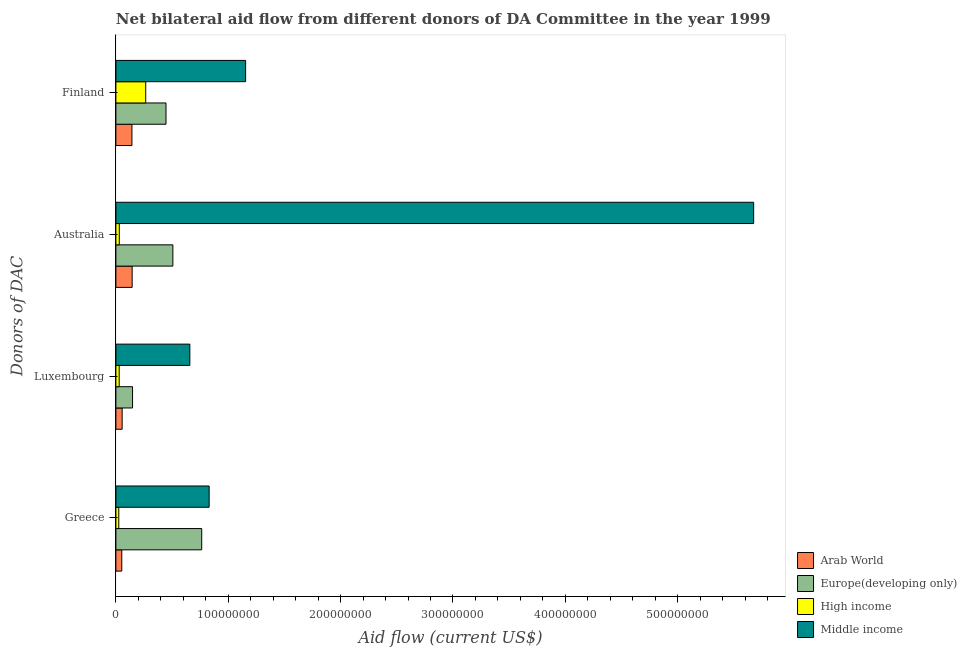How many groups of bars are there?
Ensure brevity in your answer.  4. Are the number of bars per tick equal to the number of legend labels?
Your answer should be very brief. Yes. How many bars are there on the 3rd tick from the bottom?
Your answer should be compact. 4. What is the label of the 3rd group of bars from the top?
Provide a succinct answer. Luxembourg. What is the amount of aid given by australia in High income?
Provide a succinct answer. 3.03e+06. Across all countries, what is the maximum amount of aid given by australia?
Provide a short and direct response. 5.68e+08. Across all countries, what is the minimum amount of aid given by finland?
Offer a very short reply. 1.43e+07. What is the total amount of aid given by finland in the graph?
Provide a short and direct response. 2.01e+08. What is the difference between the amount of aid given by greece in Arab World and that in High income?
Make the answer very short. 2.67e+06. What is the difference between the amount of aid given by australia in Europe(developing only) and the amount of aid given by finland in Arab World?
Keep it short and to the point. 3.64e+07. What is the average amount of aid given by luxembourg per country?
Provide a succinct answer. 2.23e+07. What is the difference between the amount of aid given by australia and amount of aid given by finland in Europe(developing only)?
Offer a terse response. 6.12e+06. What is the ratio of the amount of aid given by finland in Arab World to that in Europe(developing only)?
Provide a succinct answer. 0.32. What is the difference between the highest and the second highest amount of aid given by finland?
Keep it short and to the point. 7.09e+07. What is the difference between the highest and the lowest amount of aid given by luxembourg?
Ensure brevity in your answer.  6.29e+07. Is the sum of the amount of aid given by greece in High income and Europe(developing only) greater than the maximum amount of aid given by finland across all countries?
Your answer should be very brief. No. What does the 1st bar from the bottom in Luxembourg represents?
Offer a terse response. Arab World. Is it the case that in every country, the sum of the amount of aid given by greece and amount of aid given by luxembourg is greater than the amount of aid given by australia?
Your response must be concise. No. Are all the bars in the graph horizontal?
Your response must be concise. Yes. How many countries are there in the graph?
Your answer should be compact. 4. How are the legend labels stacked?
Keep it short and to the point. Vertical. What is the title of the graph?
Ensure brevity in your answer.  Net bilateral aid flow from different donors of DA Committee in the year 1999. What is the label or title of the X-axis?
Offer a terse response. Aid flow (current US$). What is the label or title of the Y-axis?
Keep it short and to the point. Donors of DAC. What is the Aid flow (current US$) of Arab World in Greece?
Your answer should be compact. 5.24e+06. What is the Aid flow (current US$) of Europe(developing only) in Greece?
Your answer should be very brief. 7.64e+07. What is the Aid flow (current US$) in High income in Greece?
Make the answer very short. 2.57e+06. What is the Aid flow (current US$) in Middle income in Greece?
Give a very brief answer. 8.30e+07. What is the Aid flow (current US$) of Arab World in Luxembourg?
Your answer should be very brief. 5.58e+06. What is the Aid flow (current US$) of Europe(developing only) in Luxembourg?
Provide a succinct answer. 1.48e+07. What is the Aid flow (current US$) in High income in Luxembourg?
Your answer should be compact. 2.93e+06. What is the Aid flow (current US$) in Middle income in Luxembourg?
Your response must be concise. 6.58e+07. What is the Aid flow (current US$) in Arab World in Australia?
Provide a short and direct response. 1.45e+07. What is the Aid flow (current US$) in Europe(developing only) in Australia?
Your answer should be very brief. 5.07e+07. What is the Aid flow (current US$) of High income in Australia?
Offer a terse response. 3.03e+06. What is the Aid flow (current US$) of Middle income in Australia?
Offer a terse response. 5.68e+08. What is the Aid flow (current US$) in Arab World in Finland?
Your answer should be very brief. 1.43e+07. What is the Aid flow (current US$) in Europe(developing only) in Finland?
Give a very brief answer. 4.46e+07. What is the Aid flow (current US$) in High income in Finland?
Offer a very short reply. 2.66e+07. What is the Aid flow (current US$) in Middle income in Finland?
Ensure brevity in your answer.  1.15e+08. Across all Donors of DAC, what is the maximum Aid flow (current US$) in Arab World?
Your answer should be compact. 1.45e+07. Across all Donors of DAC, what is the maximum Aid flow (current US$) in Europe(developing only)?
Give a very brief answer. 7.64e+07. Across all Donors of DAC, what is the maximum Aid flow (current US$) of High income?
Provide a succinct answer. 2.66e+07. Across all Donors of DAC, what is the maximum Aid flow (current US$) in Middle income?
Your answer should be compact. 5.68e+08. Across all Donors of DAC, what is the minimum Aid flow (current US$) of Arab World?
Your response must be concise. 5.24e+06. Across all Donors of DAC, what is the minimum Aid flow (current US$) in Europe(developing only)?
Offer a terse response. 1.48e+07. Across all Donors of DAC, what is the minimum Aid flow (current US$) of High income?
Your response must be concise. 2.57e+06. Across all Donors of DAC, what is the minimum Aid flow (current US$) of Middle income?
Give a very brief answer. 6.58e+07. What is the total Aid flow (current US$) in Arab World in the graph?
Keep it short and to the point. 3.96e+07. What is the total Aid flow (current US$) in Europe(developing only) in the graph?
Provide a succinct answer. 1.87e+08. What is the total Aid flow (current US$) in High income in the graph?
Your answer should be very brief. 3.51e+07. What is the total Aid flow (current US$) in Middle income in the graph?
Your answer should be very brief. 8.32e+08. What is the difference between the Aid flow (current US$) of Europe(developing only) in Greece and that in Luxembourg?
Provide a short and direct response. 6.16e+07. What is the difference between the Aid flow (current US$) of High income in Greece and that in Luxembourg?
Keep it short and to the point. -3.60e+05. What is the difference between the Aid flow (current US$) of Middle income in Greece and that in Luxembourg?
Give a very brief answer. 1.72e+07. What is the difference between the Aid flow (current US$) in Arab World in Greece and that in Australia?
Your answer should be compact. -9.24e+06. What is the difference between the Aid flow (current US$) of Europe(developing only) in Greece and that in Australia?
Provide a short and direct response. 2.57e+07. What is the difference between the Aid flow (current US$) in High income in Greece and that in Australia?
Your response must be concise. -4.60e+05. What is the difference between the Aid flow (current US$) of Middle income in Greece and that in Australia?
Your response must be concise. -4.85e+08. What is the difference between the Aid flow (current US$) in Arab World in Greece and that in Finland?
Ensure brevity in your answer.  -9.04e+06. What is the difference between the Aid flow (current US$) in Europe(developing only) in Greece and that in Finland?
Keep it short and to the point. 3.18e+07. What is the difference between the Aid flow (current US$) of High income in Greece and that in Finland?
Provide a short and direct response. -2.40e+07. What is the difference between the Aid flow (current US$) of Middle income in Greece and that in Finland?
Offer a terse response. -3.25e+07. What is the difference between the Aid flow (current US$) of Arab World in Luxembourg and that in Australia?
Your response must be concise. -8.90e+06. What is the difference between the Aid flow (current US$) in Europe(developing only) in Luxembourg and that in Australia?
Offer a terse response. -3.59e+07. What is the difference between the Aid flow (current US$) in High income in Luxembourg and that in Australia?
Provide a short and direct response. -1.00e+05. What is the difference between the Aid flow (current US$) in Middle income in Luxembourg and that in Australia?
Keep it short and to the point. -5.02e+08. What is the difference between the Aid flow (current US$) in Arab World in Luxembourg and that in Finland?
Make the answer very short. -8.70e+06. What is the difference between the Aid flow (current US$) in Europe(developing only) in Luxembourg and that in Finland?
Keep it short and to the point. -2.98e+07. What is the difference between the Aid flow (current US$) of High income in Luxembourg and that in Finland?
Provide a succinct answer. -2.36e+07. What is the difference between the Aid flow (current US$) of Middle income in Luxembourg and that in Finland?
Your answer should be very brief. -4.96e+07. What is the difference between the Aid flow (current US$) of Arab World in Australia and that in Finland?
Give a very brief answer. 2.00e+05. What is the difference between the Aid flow (current US$) in Europe(developing only) in Australia and that in Finland?
Give a very brief answer. 6.12e+06. What is the difference between the Aid flow (current US$) in High income in Australia and that in Finland?
Make the answer very short. -2.35e+07. What is the difference between the Aid flow (current US$) of Middle income in Australia and that in Finland?
Your answer should be very brief. 4.52e+08. What is the difference between the Aid flow (current US$) of Arab World in Greece and the Aid flow (current US$) of Europe(developing only) in Luxembourg?
Give a very brief answer. -9.59e+06. What is the difference between the Aid flow (current US$) in Arab World in Greece and the Aid flow (current US$) in High income in Luxembourg?
Make the answer very short. 2.31e+06. What is the difference between the Aid flow (current US$) in Arab World in Greece and the Aid flow (current US$) in Middle income in Luxembourg?
Give a very brief answer. -6.06e+07. What is the difference between the Aid flow (current US$) in Europe(developing only) in Greece and the Aid flow (current US$) in High income in Luxembourg?
Make the answer very short. 7.34e+07. What is the difference between the Aid flow (current US$) in Europe(developing only) in Greece and the Aid flow (current US$) in Middle income in Luxembourg?
Offer a terse response. 1.06e+07. What is the difference between the Aid flow (current US$) in High income in Greece and the Aid flow (current US$) in Middle income in Luxembourg?
Your answer should be very brief. -6.32e+07. What is the difference between the Aid flow (current US$) in Arab World in Greece and the Aid flow (current US$) in Europe(developing only) in Australia?
Your response must be concise. -4.55e+07. What is the difference between the Aid flow (current US$) in Arab World in Greece and the Aid flow (current US$) in High income in Australia?
Your answer should be compact. 2.21e+06. What is the difference between the Aid flow (current US$) of Arab World in Greece and the Aid flow (current US$) of Middle income in Australia?
Provide a succinct answer. -5.62e+08. What is the difference between the Aid flow (current US$) of Europe(developing only) in Greece and the Aid flow (current US$) of High income in Australia?
Provide a succinct answer. 7.34e+07. What is the difference between the Aid flow (current US$) in Europe(developing only) in Greece and the Aid flow (current US$) in Middle income in Australia?
Your answer should be compact. -4.91e+08. What is the difference between the Aid flow (current US$) in High income in Greece and the Aid flow (current US$) in Middle income in Australia?
Give a very brief answer. -5.65e+08. What is the difference between the Aid flow (current US$) of Arab World in Greece and the Aid flow (current US$) of Europe(developing only) in Finland?
Offer a very short reply. -3.94e+07. What is the difference between the Aid flow (current US$) in Arab World in Greece and the Aid flow (current US$) in High income in Finland?
Offer a terse response. -2.13e+07. What is the difference between the Aid flow (current US$) in Arab World in Greece and the Aid flow (current US$) in Middle income in Finland?
Keep it short and to the point. -1.10e+08. What is the difference between the Aid flow (current US$) of Europe(developing only) in Greece and the Aid flow (current US$) of High income in Finland?
Offer a terse response. 4.98e+07. What is the difference between the Aid flow (current US$) in Europe(developing only) in Greece and the Aid flow (current US$) in Middle income in Finland?
Your response must be concise. -3.91e+07. What is the difference between the Aid flow (current US$) of High income in Greece and the Aid flow (current US$) of Middle income in Finland?
Ensure brevity in your answer.  -1.13e+08. What is the difference between the Aid flow (current US$) of Arab World in Luxembourg and the Aid flow (current US$) of Europe(developing only) in Australia?
Offer a terse response. -4.51e+07. What is the difference between the Aid flow (current US$) in Arab World in Luxembourg and the Aid flow (current US$) in High income in Australia?
Your answer should be compact. 2.55e+06. What is the difference between the Aid flow (current US$) of Arab World in Luxembourg and the Aid flow (current US$) of Middle income in Australia?
Provide a short and direct response. -5.62e+08. What is the difference between the Aid flow (current US$) in Europe(developing only) in Luxembourg and the Aid flow (current US$) in High income in Australia?
Offer a very short reply. 1.18e+07. What is the difference between the Aid flow (current US$) of Europe(developing only) in Luxembourg and the Aid flow (current US$) of Middle income in Australia?
Ensure brevity in your answer.  -5.53e+08. What is the difference between the Aid flow (current US$) of High income in Luxembourg and the Aid flow (current US$) of Middle income in Australia?
Make the answer very short. -5.65e+08. What is the difference between the Aid flow (current US$) in Arab World in Luxembourg and the Aid flow (current US$) in Europe(developing only) in Finland?
Provide a short and direct response. -3.90e+07. What is the difference between the Aid flow (current US$) of Arab World in Luxembourg and the Aid flow (current US$) of High income in Finland?
Offer a very short reply. -2.10e+07. What is the difference between the Aid flow (current US$) of Arab World in Luxembourg and the Aid flow (current US$) of Middle income in Finland?
Your answer should be compact. -1.10e+08. What is the difference between the Aid flow (current US$) in Europe(developing only) in Luxembourg and the Aid flow (current US$) in High income in Finland?
Give a very brief answer. -1.17e+07. What is the difference between the Aid flow (current US$) in Europe(developing only) in Luxembourg and the Aid flow (current US$) in Middle income in Finland?
Your response must be concise. -1.01e+08. What is the difference between the Aid flow (current US$) in High income in Luxembourg and the Aid flow (current US$) in Middle income in Finland?
Ensure brevity in your answer.  -1.13e+08. What is the difference between the Aid flow (current US$) of Arab World in Australia and the Aid flow (current US$) of Europe(developing only) in Finland?
Offer a terse response. -3.01e+07. What is the difference between the Aid flow (current US$) of Arab World in Australia and the Aid flow (current US$) of High income in Finland?
Ensure brevity in your answer.  -1.21e+07. What is the difference between the Aid flow (current US$) of Arab World in Australia and the Aid flow (current US$) of Middle income in Finland?
Keep it short and to the point. -1.01e+08. What is the difference between the Aid flow (current US$) in Europe(developing only) in Australia and the Aid flow (current US$) in High income in Finland?
Your response must be concise. 2.42e+07. What is the difference between the Aid flow (current US$) of Europe(developing only) in Australia and the Aid flow (current US$) of Middle income in Finland?
Your answer should be very brief. -6.47e+07. What is the difference between the Aid flow (current US$) of High income in Australia and the Aid flow (current US$) of Middle income in Finland?
Provide a short and direct response. -1.12e+08. What is the average Aid flow (current US$) of Arab World per Donors of DAC?
Provide a succinct answer. 9.90e+06. What is the average Aid flow (current US$) in Europe(developing only) per Donors of DAC?
Provide a succinct answer. 4.66e+07. What is the average Aid flow (current US$) of High income per Donors of DAC?
Offer a very short reply. 8.77e+06. What is the average Aid flow (current US$) in Middle income per Donors of DAC?
Ensure brevity in your answer.  2.08e+08. What is the difference between the Aid flow (current US$) in Arab World and Aid flow (current US$) in Europe(developing only) in Greece?
Provide a short and direct response. -7.11e+07. What is the difference between the Aid flow (current US$) of Arab World and Aid flow (current US$) of High income in Greece?
Keep it short and to the point. 2.67e+06. What is the difference between the Aid flow (current US$) of Arab World and Aid flow (current US$) of Middle income in Greece?
Offer a terse response. -7.78e+07. What is the difference between the Aid flow (current US$) of Europe(developing only) and Aid flow (current US$) of High income in Greece?
Make the answer very short. 7.38e+07. What is the difference between the Aid flow (current US$) of Europe(developing only) and Aid flow (current US$) of Middle income in Greece?
Ensure brevity in your answer.  -6.61e+06. What is the difference between the Aid flow (current US$) of High income and Aid flow (current US$) of Middle income in Greece?
Make the answer very short. -8.04e+07. What is the difference between the Aid flow (current US$) in Arab World and Aid flow (current US$) in Europe(developing only) in Luxembourg?
Your answer should be compact. -9.25e+06. What is the difference between the Aid flow (current US$) of Arab World and Aid flow (current US$) of High income in Luxembourg?
Give a very brief answer. 2.65e+06. What is the difference between the Aid flow (current US$) of Arab World and Aid flow (current US$) of Middle income in Luxembourg?
Ensure brevity in your answer.  -6.02e+07. What is the difference between the Aid flow (current US$) of Europe(developing only) and Aid flow (current US$) of High income in Luxembourg?
Give a very brief answer. 1.19e+07. What is the difference between the Aid flow (current US$) in Europe(developing only) and Aid flow (current US$) in Middle income in Luxembourg?
Ensure brevity in your answer.  -5.10e+07. What is the difference between the Aid flow (current US$) in High income and Aid flow (current US$) in Middle income in Luxembourg?
Your answer should be very brief. -6.29e+07. What is the difference between the Aid flow (current US$) in Arab World and Aid flow (current US$) in Europe(developing only) in Australia?
Your answer should be very brief. -3.62e+07. What is the difference between the Aid flow (current US$) of Arab World and Aid flow (current US$) of High income in Australia?
Offer a terse response. 1.14e+07. What is the difference between the Aid flow (current US$) of Arab World and Aid flow (current US$) of Middle income in Australia?
Your response must be concise. -5.53e+08. What is the difference between the Aid flow (current US$) of Europe(developing only) and Aid flow (current US$) of High income in Australia?
Your answer should be compact. 4.77e+07. What is the difference between the Aid flow (current US$) in Europe(developing only) and Aid flow (current US$) in Middle income in Australia?
Provide a succinct answer. -5.17e+08. What is the difference between the Aid flow (current US$) in High income and Aid flow (current US$) in Middle income in Australia?
Give a very brief answer. -5.65e+08. What is the difference between the Aid flow (current US$) in Arab World and Aid flow (current US$) in Europe(developing only) in Finland?
Your answer should be compact. -3.03e+07. What is the difference between the Aid flow (current US$) in Arab World and Aid flow (current US$) in High income in Finland?
Keep it short and to the point. -1.23e+07. What is the difference between the Aid flow (current US$) in Arab World and Aid flow (current US$) in Middle income in Finland?
Offer a very short reply. -1.01e+08. What is the difference between the Aid flow (current US$) of Europe(developing only) and Aid flow (current US$) of High income in Finland?
Offer a terse response. 1.80e+07. What is the difference between the Aid flow (current US$) in Europe(developing only) and Aid flow (current US$) in Middle income in Finland?
Provide a short and direct response. -7.09e+07. What is the difference between the Aid flow (current US$) of High income and Aid flow (current US$) of Middle income in Finland?
Your answer should be very brief. -8.89e+07. What is the ratio of the Aid flow (current US$) in Arab World in Greece to that in Luxembourg?
Provide a succinct answer. 0.94. What is the ratio of the Aid flow (current US$) in Europe(developing only) in Greece to that in Luxembourg?
Your answer should be compact. 5.15. What is the ratio of the Aid flow (current US$) of High income in Greece to that in Luxembourg?
Your response must be concise. 0.88. What is the ratio of the Aid flow (current US$) in Middle income in Greece to that in Luxembourg?
Give a very brief answer. 1.26. What is the ratio of the Aid flow (current US$) in Arab World in Greece to that in Australia?
Your response must be concise. 0.36. What is the ratio of the Aid flow (current US$) in Europe(developing only) in Greece to that in Australia?
Offer a very short reply. 1.51. What is the ratio of the Aid flow (current US$) of High income in Greece to that in Australia?
Give a very brief answer. 0.85. What is the ratio of the Aid flow (current US$) in Middle income in Greece to that in Australia?
Offer a very short reply. 0.15. What is the ratio of the Aid flow (current US$) of Arab World in Greece to that in Finland?
Ensure brevity in your answer.  0.37. What is the ratio of the Aid flow (current US$) in Europe(developing only) in Greece to that in Finland?
Offer a terse response. 1.71. What is the ratio of the Aid flow (current US$) in High income in Greece to that in Finland?
Give a very brief answer. 0.1. What is the ratio of the Aid flow (current US$) in Middle income in Greece to that in Finland?
Ensure brevity in your answer.  0.72. What is the ratio of the Aid flow (current US$) in Arab World in Luxembourg to that in Australia?
Your response must be concise. 0.39. What is the ratio of the Aid flow (current US$) of Europe(developing only) in Luxembourg to that in Australia?
Make the answer very short. 0.29. What is the ratio of the Aid flow (current US$) in Middle income in Luxembourg to that in Australia?
Offer a very short reply. 0.12. What is the ratio of the Aid flow (current US$) in Arab World in Luxembourg to that in Finland?
Give a very brief answer. 0.39. What is the ratio of the Aid flow (current US$) of Europe(developing only) in Luxembourg to that in Finland?
Provide a short and direct response. 0.33. What is the ratio of the Aid flow (current US$) in High income in Luxembourg to that in Finland?
Provide a short and direct response. 0.11. What is the ratio of the Aid flow (current US$) of Middle income in Luxembourg to that in Finland?
Your answer should be compact. 0.57. What is the ratio of the Aid flow (current US$) of Arab World in Australia to that in Finland?
Your response must be concise. 1.01. What is the ratio of the Aid flow (current US$) of Europe(developing only) in Australia to that in Finland?
Make the answer very short. 1.14. What is the ratio of the Aid flow (current US$) of High income in Australia to that in Finland?
Your answer should be compact. 0.11. What is the ratio of the Aid flow (current US$) of Middle income in Australia to that in Finland?
Keep it short and to the point. 4.92. What is the difference between the highest and the second highest Aid flow (current US$) of Arab World?
Keep it short and to the point. 2.00e+05. What is the difference between the highest and the second highest Aid flow (current US$) of Europe(developing only)?
Keep it short and to the point. 2.57e+07. What is the difference between the highest and the second highest Aid flow (current US$) in High income?
Offer a terse response. 2.35e+07. What is the difference between the highest and the second highest Aid flow (current US$) of Middle income?
Offer a terse response. 4.52e+08. What is the difference between the highest and the lowest Aid flow (current US$) in Arab World?
Give a very brief answer. 9.24e+06. What is the difference between the highest and the lowest Aid flow (current US$) in Europe(developing only)?
Your answer should be compact. 6.16e+07. What is the difference between the highest and the lowest Aid flow (current US$) of High income?
Provide a short and direct response. 2.40e+07. What is the difference between the highest and the lowest Aid flow (current US$) of Middle income?
Make the answer very short. 5.02e+08. 